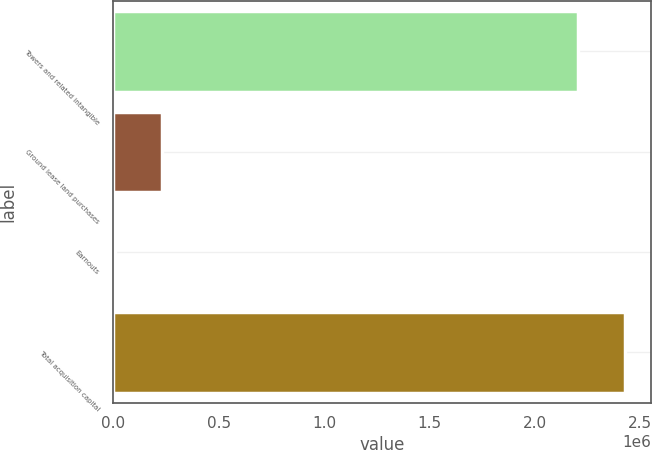Convert chart. <chart><loc_0><loc_0><loc_500><loc_500><bar_chart><fcel>Towers and related intangible<fcel>Ground lease land purchases<fcel>Earnouts<fcel>Total acquisition capital<nl><fcel>2.20586e+06<fcel>231203<fcel>5931<fcel>2.43113e+06<nl></chart> 